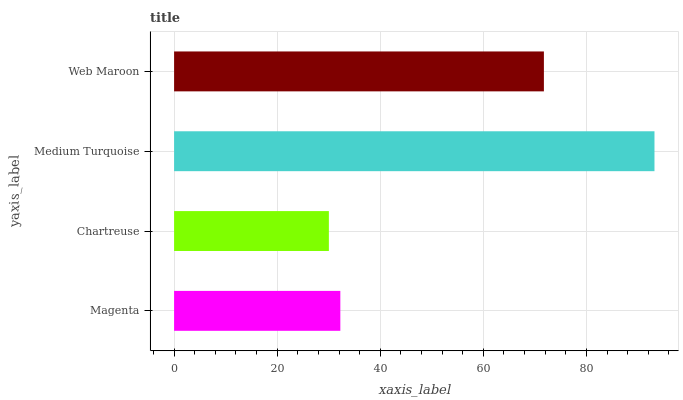Is Chartreuse the minimum?
Answer yes or no. Yes. Is Medium Turquoise the maximum?
Answer yes or no. Yes. Is Medium Turquoise the minimum?
Answer yes or no. No. Is Chartreuse the maximum?
Answer yes or no. No. Is Medium Turquoise greater than Chartreuse?
Answer yes or no. Yes. Is Chartreuse less than Medium Turquoise?
Answer yes or no. Yes. Is Chartreuse greater than Medium Turquoise?
Answer yes or no. No. Is Medium Turquoise less than Chartreuse?
Answer yes or no. No. Is Web Maroon the high median?
Answer yes or no. Yes. Is Magenta the low median?
Answer yes or no. Yes. Is Chartreuse the high median?
Answer yes or no. No. Is Chartreuse the low median?
Answer yes or no. No. 